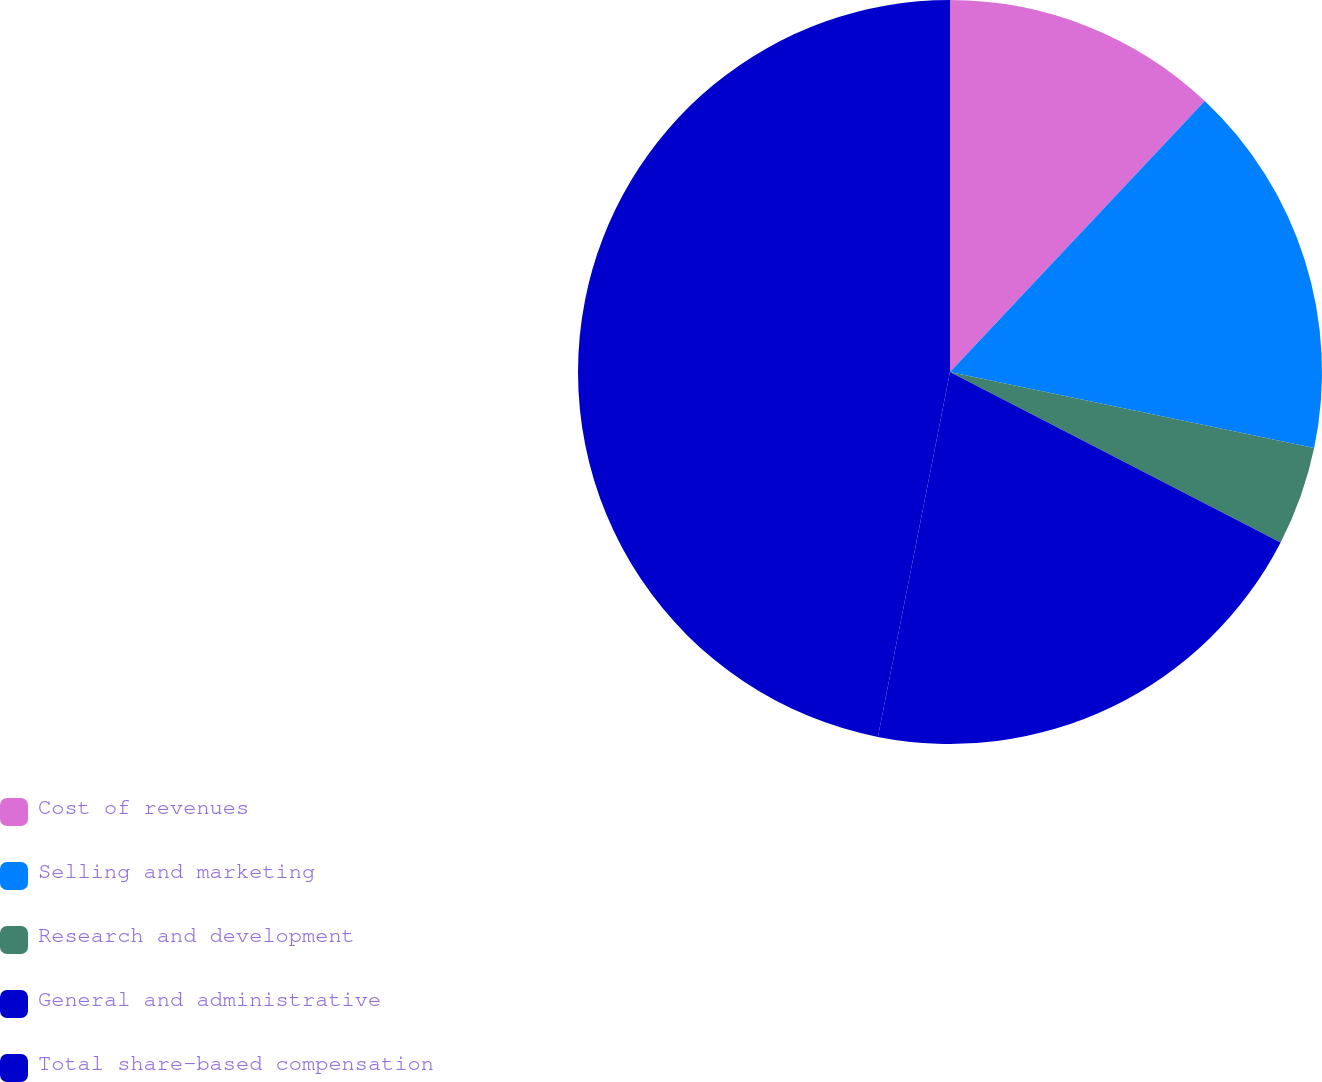Convert chart. <chart><loc_0><loc_0><loc_500><loc_500><pie_chart><fcel>Cost of revenues<fcel>Selling and marketing<fcel>Research and development<fcel>General and administrative<fcel>Total share-based compensation<nl><fcel>12.01%<fcel>16.27%<fcel>4.3%<fcel>20.53%<fcel>46.9%<nl></chart> 